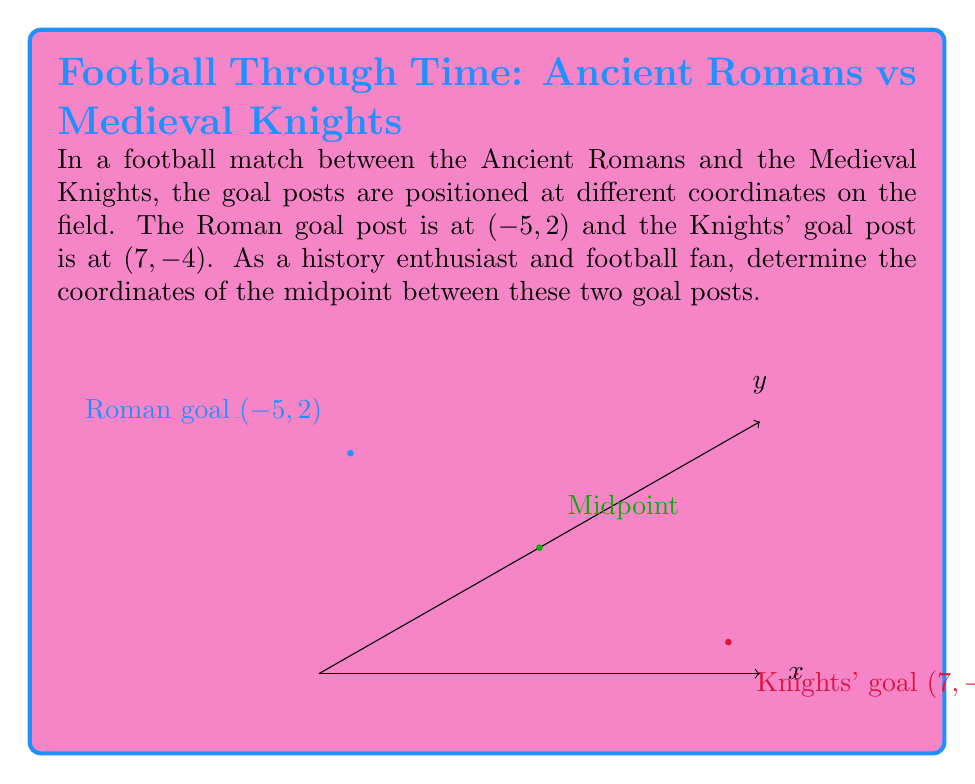Could you help me with this problem? To find the midpoint between two points, we use the midpoint formula:

$$ \text{Midpoint} = \left(\frac{x_1 + x_2}{2}, \frac{y_1 + y_2}{2}\right) $$

Where $(x_1, y_1)$ is the coordinate of the first point and $(x_2, y_2)$ is the coordinate of the second point.

Given:
- Roman goal post: $(-5, 2)$
- Knights' goal post: $(7, -4)$

Step 1: Calculate the x-coordinate of the midpoint:
$$ x = \frac{x_1 + x_2}{2} = \frac{-5 + 7}{2} = \frac{2}{2} = 1 $$

Step 2: Calculate the y-coordinate of the midpoint:
$$ y = \frac{y_1 + y_2}{2} = \frac{2 + (-4)}{2} = \frac{-2}{2} = -1 $$

Therefore, the midpoint coordinates are $(1, -1)$.
Answer: $(1, -1)$ 